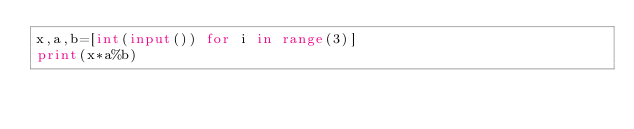<code> <loc_0><loc_0><loc_500><loc_500><_Python_>x,a,b=[int(input()) for i in range(3)]
print(x*a%b)</code> 